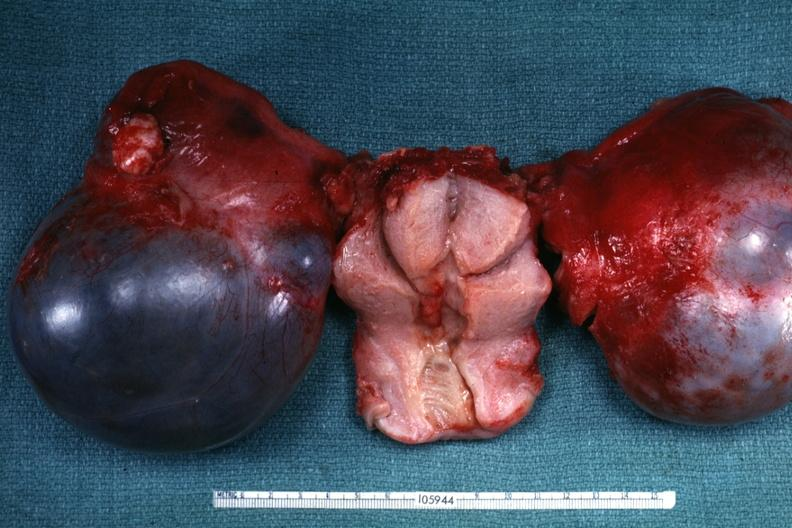what is present?
Answer the question using a single word or phrase. Female reproductive 